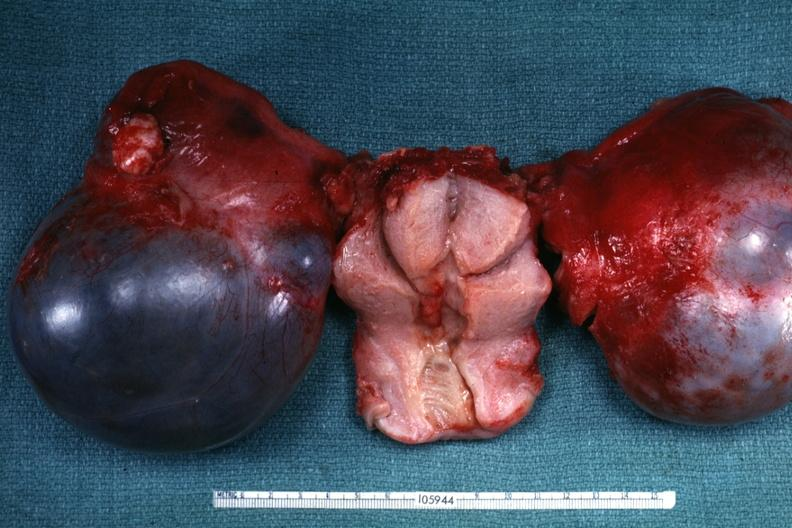what is present?
Answer the question using a single word or phrase. Female reproductive 